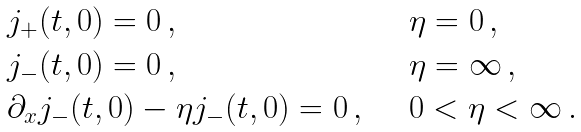Convert formula to latex. <formula><loc_0><loc_0><loc_500><loc_500>\begin{array} { l l } j _ { + } ( t , 0 ) = 0 \, , & \quad \eta = 0 \, , \\ j _ { - } ( t , 0 ) = 0 \, , & \quad \eta = \infty \, , \\ \partial _ { x } j _ { - } ( t , 0 ) - \eta j _ { - } ( t , 0 ) = 0 \, , & \quad 0 < \eta < \infty \, . \end{array}</formula> 